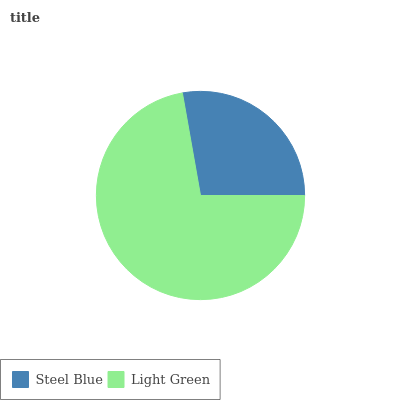Is Steel Blue the minimum?
Answer yes or no. Yes. Is Light Green the maximum?
Answer yes or no. Yes. Is Light Green the minimum?
Answer yes or no. No. Is Light Green greater than Steel Blue?
Answer yes or no. Yes. Is Steel Blue less than Light Green?
Answer yes or no. Yes. Is Steel Blue greater than Light Green?
Answer yes or no. No. Is Light Green less than Steel Blue?
Answer yes or no. No. Is Light Green the high median?
Answer yes or no. Yes. Is Steel Blue the low median?
Answer yes or no. Yes. Is Steel Blue the high median?
Answer yes or no. No. Is Light Green the low median?
Answer yes or no. No. 